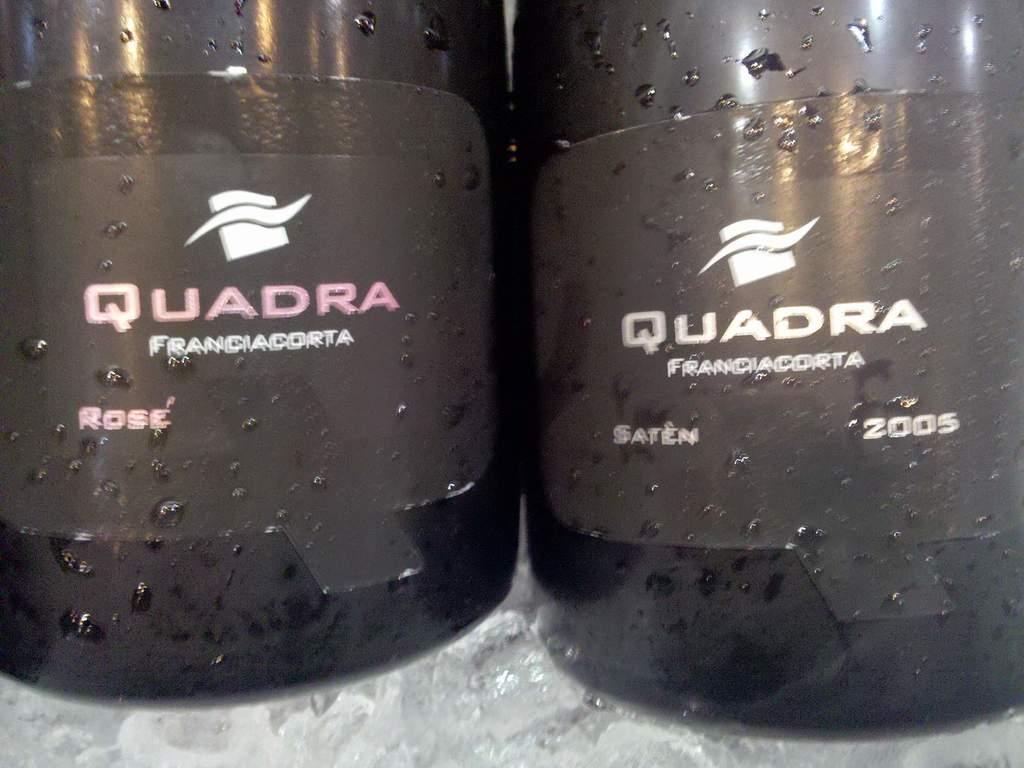In one or two sentences, can you explain what this image depicts? At the bottom of the image there is a table, on the table there two bottles. On the bottles we can see alphabets and numbers. 